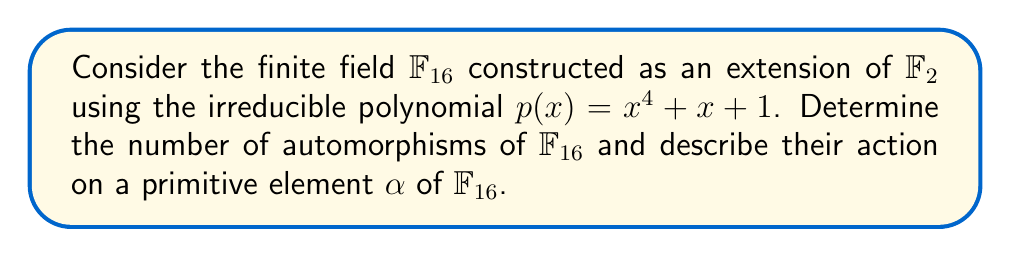What is the answer to this math problem? 1. The automorphisms of a finite field $\mathbb{F}_{p^n}$ form a cyclic group of order $n$, generated by the Frobenius automorphism.

2. In this case, $\mathbb{F}_{16} = \mathbb{F}_{2^4}$, so $n = 4$.

3. The Frobenius automorphism $\sigma$ is defined as $\sigma(x) = x^2$ for all $x \in \mathbb{F}_{16}$.

4. The automorphisms of $\mathbb{F}_{16}$ are:
   $id, \sigma, \sigma^2, \sigma^3$

5. Let $\alpha$ be a primitive element of $\mathbb{F}_{16}$. Then:
   $\sigma(\alpha) = \alpha^2$
   $\sigma^2(\alpha) = \alpha^4$
   $\sigma^3(\alpha) = \alpha^8$

6. Note that $\sigma^4(\alpha) = \alpha^{16} = \alpha$, as $\alpha^{15} = 1$ in $\mathbb{F}_{16}$.

7. The action of these automorphisms on any element of $\mathbb{F}_{16}$ can be described as repeated squaring in the field.

8. This result is independent of religious beliefs or cultural context, aligning with the logical and empirical nature of mathematics, which may appeal to the given persona.
Answer: 4 automorphisms: $id, \sigma, \sigma^2, \sigma^3$, where $\sigma(\alpha) = \alpha^2$. 